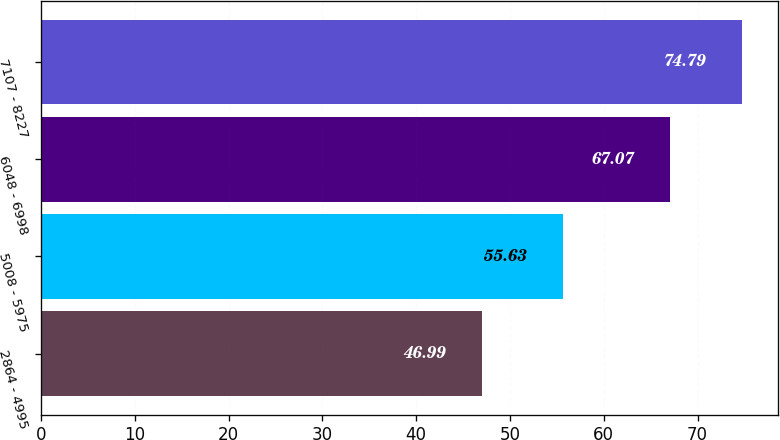<chart> <loc_0><loc_0><loc_500><loc_500><bar_chart><fcel>2864 - 4995<fcel>5008 - 5975<fcel>6048 - 6998<fcel>7107 - 8227<nl><fcel>46.99<fcel>55.63<fcel>67.07<fcel>74.79<nl></chart> 